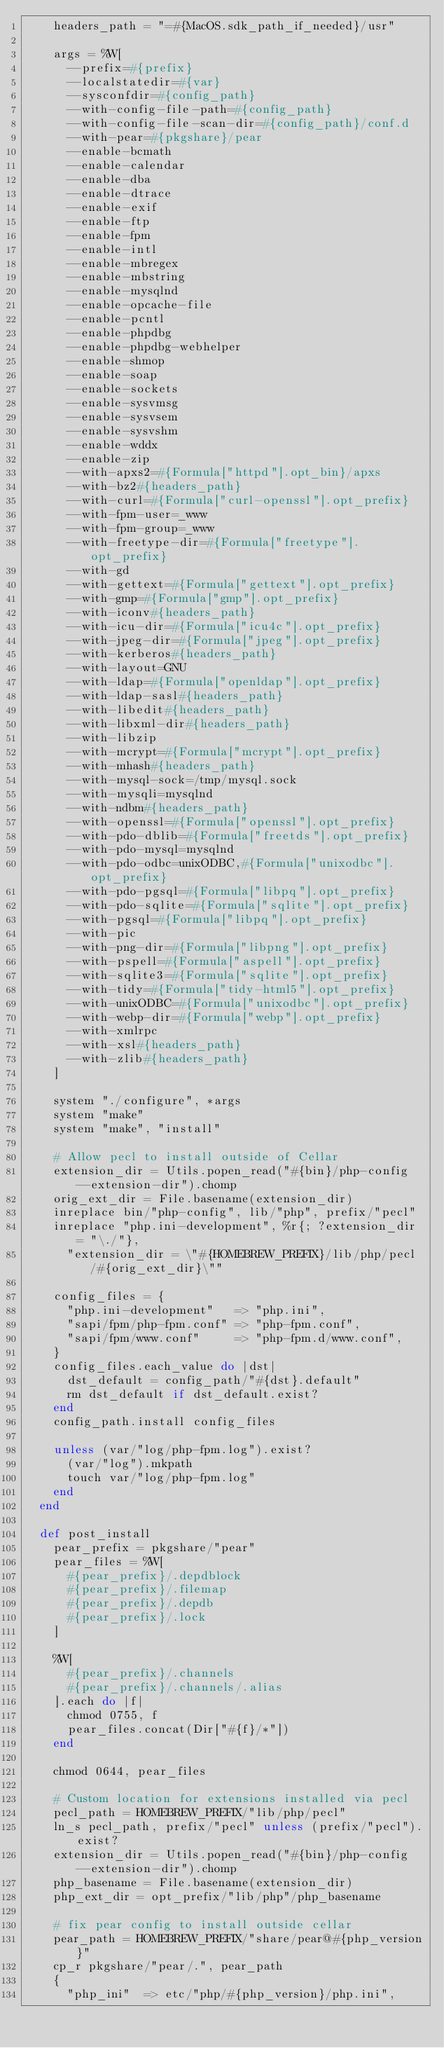<code> <loc_0><loc_0><loc_500><loc_500><_Ruby_>    headers_path = "=#{MacOS.sdk_path_if_needed}/usr"

    args = %W[
      --prefix=#{prefix}
      --localstatedir=#{var}
      --sysconfdir=#{config_path}
      --with-config-file-path=#{config_path}
      --with-config-file-scan-dir=#{config_path}/conf.d
      --with-pear=#{pkgshare}/pear
      --enable-bcmath
      --enable-calendar
      --enable-dba
      --enable-dtrace
      --enable-exif
      --enable-ftp
      --enable-fpm
      --enable-intl
      --enable-mbregex
      --enable-mbstring
      --enable-mysqlnd
      --enable-opcache-file
      --enable-pcntl
      --enable-phpdbg
      --enable-phpdbg-webhelper
      --enable-shmop
      --enable-soap
      --enable-sockets
      --enable-sysvmsg
      --enable-sysvsem
      --enable-sysvshm
      --enable-wddx
      --enable-zip
      --with-apxs2=#{Formula["httpd"].opt_bin}/apxs
      --with-bz2#{headers_path}
      --with-curl=#{Formula["curl-openssl"].opt_prefix}
      --with-fpm-user=_www
      --with-fpm-group=_www
      --with-freetype-dir=#{Formula["freetype"].opt_prefix}
      --with-gd
      --with-gettext=#{Formula["gettext"].opt_prefix}
      --with-gmp=#{Formula["gmp"].opt_prefix}
      --with-iconv#{headers_path}
      --with-icu-dir=#{Formula["icu4c"].opt_prefix}
      --with-jpeg-dir=#{Formula["jpeg"].opt_prefix}
      --with-kerberos#{headers_path}
      --with-layout=GNU
      --with-ldap=#{Formula["openldap"].opt_prefix}
      --with-ldap-sasl#{headers_path}
      --with-libedit#{headers_path}
      --with-libxml-dir#{headers_path}
      --with-libzip
      --with-mcrypt=#{Formula["mcrypt"].opt_prefix}
      --with-mhash#{headers_path}
      --with-mysql-sock=/tmp/mysql.sock
      --with-mysqli=mysqlnd
      --with-ndbm#{headers_path}
      --with-openssl=#{Formula["openssl"].opt_prefix}
      --with-pdo-dblib=#{Formula["freetds"].opt_prefix}
      --with-pdo-mysql=mysqlnd
      --with-pdo-odbc=unixODBC,#{Formula["unixodbc"].opt_prefix}
      --with-pdo-pgsql=#{Formula["libpq"].opt_prefix}
      --with-pdo-sqlite=#{Formula["sqlite"].opt_prefix}
      --with-pgsql=#{Formula["libpq"].opt_prefix}
      --with-pic
      --with-png-dir=#{Formula["libpng"].opt_prefix}
      --with-pspell=#{Formula["aspell"].opt_prefix}
      --with-sqlite3=#{Formula["sqlite"].opt_prefix}
      --with-tidy=#{Formula["tidy-html5"].opt_prefix}
      --with-unixODBC=#{Formula["unixodbc"].opt_prefix}
      --with-webp-dir=#{Formula["webp"].opt_prefix}
      --with-xmlrpc
      --with-xsl#{headers_path}
      --with-zlib#{headers_path}
    ]

    system "./configure", *args
    system "make"
    system "make", "install"

    # Allow pecl to install outside of Cellar
    extension_dir = Utils.popen_read("#{bin}/php-config --extension-dir").chomp
    orig_ext_dir = File.basename(extension_dir)
    inreplace bin/"php-config", lib/"php", prefix/"pecl"
    inreplace "php.ini-development", %r{; ?extension_dir = "\./"},
      "extension_dir = \"#{HOMEBREW_PREFIX}/lib/php/pecl/#{orig_ext_dir}\""

    config_files = {
      "php.ini-development"   => "php.ini",
      "sapi/fpm/php-fpm.conf" => "php-fpm.conf",
      "sapi/fpm/www.conf"     => "php-fpm.d/www.conf",
    }
    config_files.each_value do |dst|
      dst_default = config_path/"#{dst}.default"
      rm dst_default if dst_default.exist?
    end
    config_path.install config_files

    unless (var/"log/php-fpm.log").exist?
      (var/"log").mkpath
      touch var/"log/php-fpm.log"
    end
  end

  def post_install
    pear_prefix = pkgshare/"pear"
    pear_files = %W[
      #{pear_prefix}/.depdblock
      #{pear_prefix}/.filemap
      #{pear_prefix}/.depdb
      #{pear_prefix}/.lock
    ]

    %W[
      #{pear_prefix}/.channels
      #{pear_prefix}/.channels/.alias
    ].each do |f|
      chmod 0755, f
      pear_files.concat(Dir["#{f}/*"])
    end

    chmod 0644, pear_files

    # Custom location for extensions installed via pecl
    pecl_path = HOMEBREW_PREFIX/"lib/php/pecl"
    ln_s pecl_path, prefix/"pecl" unless (prefix/"pecl").exist?
    extension_dir = Utils.popen_read("#{bin}/php-config --extension-dir").chomp
    php_basename = File.basename(extension_dir)
    php_ext_dir = opt_prefix/"lib/php"/php_basename

    # fix pear config to install outside cellar
    pear_path = HOMEBREW_PREFIX/"share/pear@#{php_version}"
    cp_r pkgshare/"pear/.", pear_path
    {
      "php_ini"  => etc/"php/#{php_version}/php.ini",</code> 